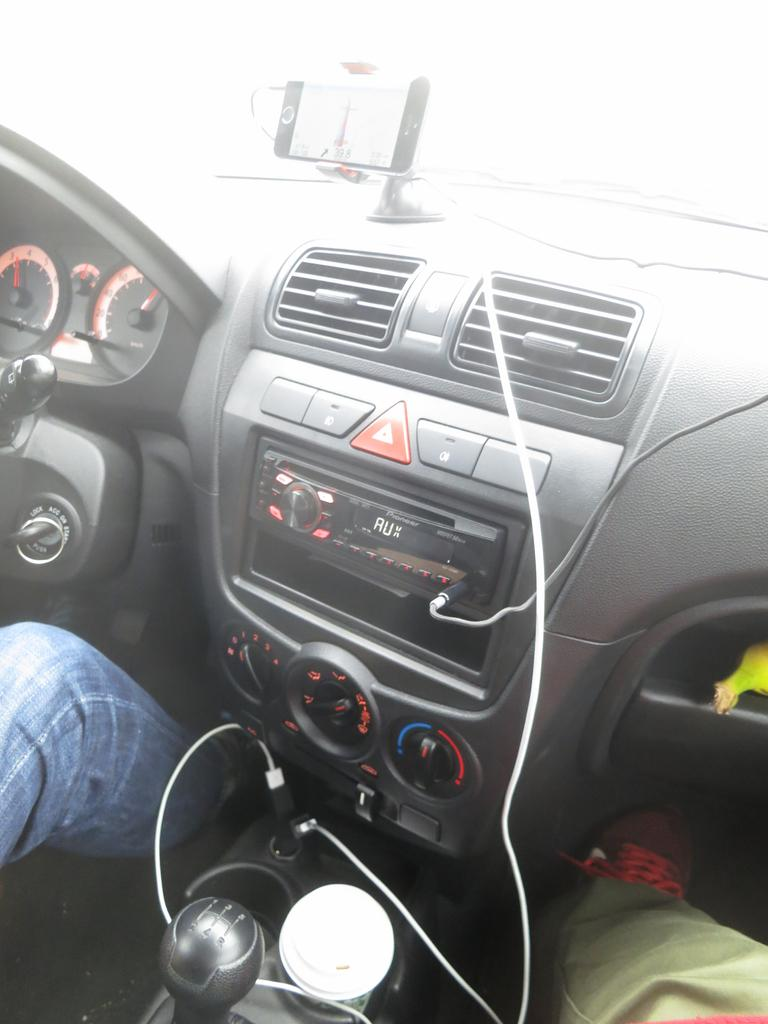What is the setting of the image? The image is taken inside a vehicle. Can you describe any visible body parts of a person in the image? There are legs of a person visible in the image. What type of control mechanism can be seen in the image? There is a gear in the image. What type of cables are present in the image? USB cables are present in the image. What type of cooling system is visible in the image? There is an AC (air conditioning) unit in the image. What type of device is visible for playing audio? An audio player is visible in the image. What type of interactive elements are present in the image? There are buttons in the image. What type of measuring devices are present in the image? Meters are present in the image. What type of device is used to hold a mobile phone in the image? There is a mobile holder with a mobile phone in the image. What type of jar is visible on the dashboard of the vehicle in the image? There is no jar visible on the dashboard of the vehicle in the image. What type of lumber is being used to construct the vehicle in the image? The image does not show any lumber being used to construct the vehicle; it is a finished vehicle. 